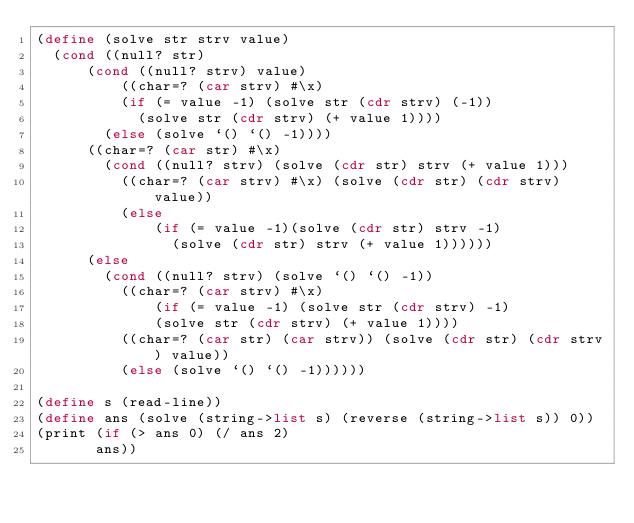Convert code to text. <code><loc_0><loc_0><loc_500><loc_500><_Scheme_>(define (solve str strv value)
	(cond ((null? str)
		  (cond ((null? strv) value)
		  		((char=? (car strv) #\x)
					(if (= value -1) (solve str (cdr strv) (-1))
						(solve str (cdr strv) (+ value 1))))
				(else (solve `() `() -1))))
		  ((char=? (car str) #\x) 
		  	(cond ((null? strv) (solve (cdr str) strv (+ value 1)))
				  ((char=? (car strv) #\x) (solve (cdr str) (cdr strv) value))
				  (else 
				      (if (= value -1)(solve (cdr str) strv -1)
					  	  (solve (cdr str) strv (+ value 1))))))
		  (else
		  	(cond ((null? strv) (solve `() `() -1))
				  ((char=? (car strv) #\x) 
				  		(if (= value -1) (solve str (cdr strv) -1)
							(solve str (cdr strv) (+ value 1))))
				  ((char=? (car str) (car strv)) (solve (cdr str) (cdr strv) value))
				  (else (solve `() `() -1))))))

(define s (read-line))
(define ans (solve (string->list s) (reverse (string->list s)) 0))
(print (if (> ans 0) (/ ans 2)
		   ans))</code> 